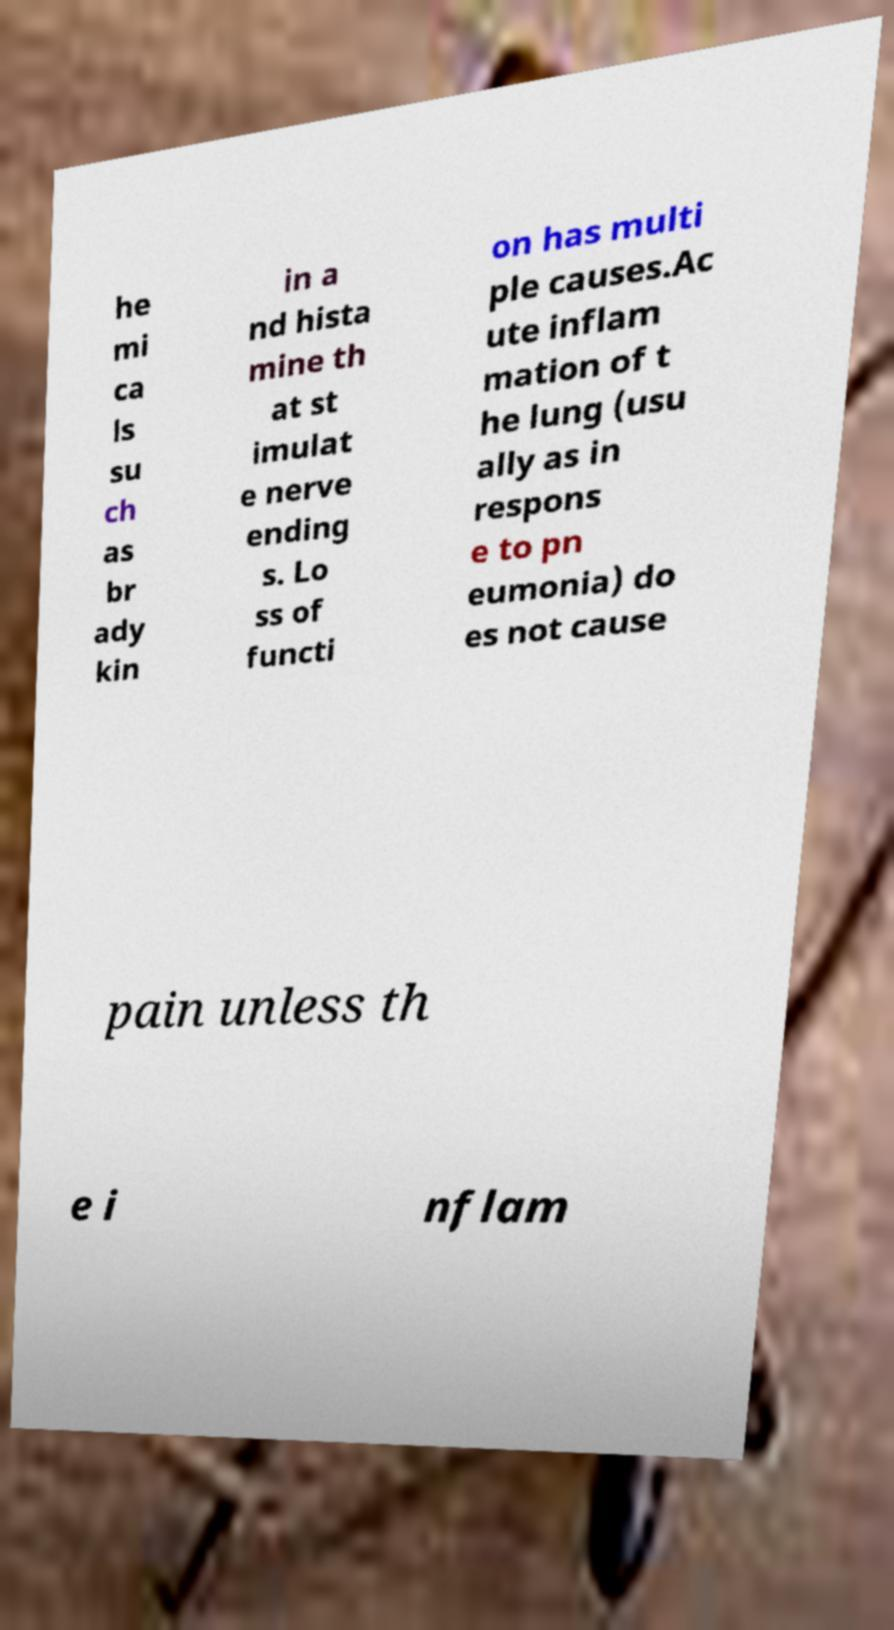What messages or text are displayed in this image? I need them in a readable, typed format. he mi ca ls su ch as br ady kin in a nd hista mine th at st imulat e nerve ending s. Lo ss of functi on has multi ple causes.Ac ute inflam mation of t he lung (usu ally as in respons e to pn eumonia) do es not cause pain unless th e i nflam 